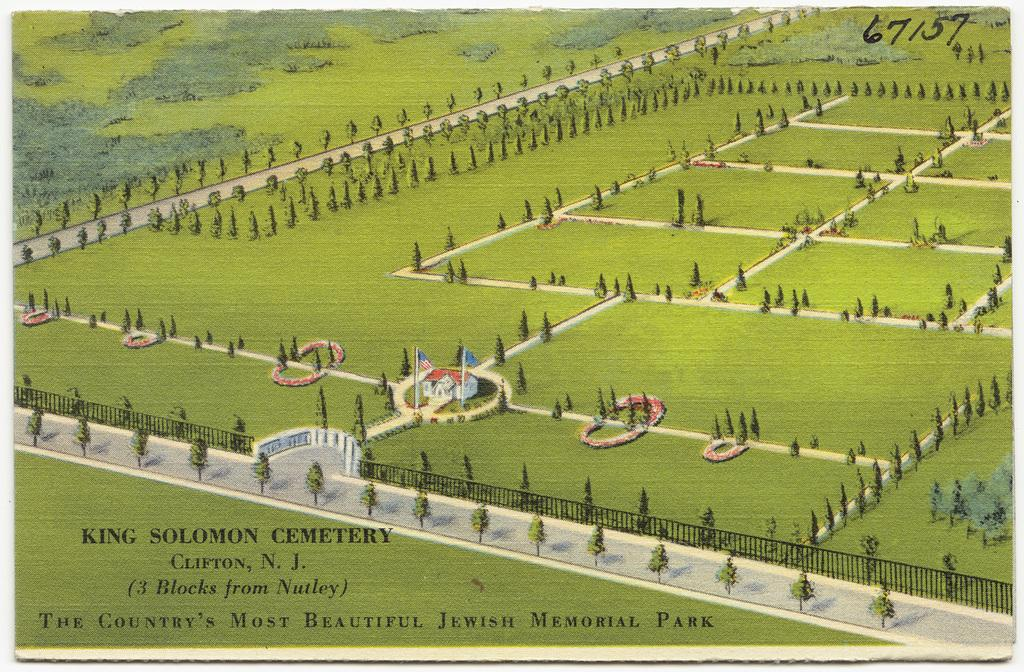Provide a one-sentence caption for the provided image. A postcard for King Solomon Cemetery features many trees. 